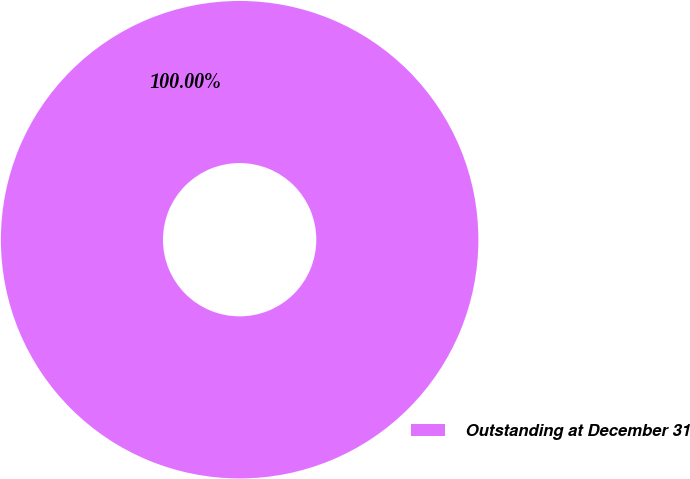Convert chart. <chart><loc_0><loc_0><loc_500><loc_500><pie_chart><fcel>Outstanding at December 31<nl><fcel>100.0%<nl></chart> 